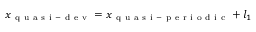<formula> <loc_0><loc_0><loc_500><loc_500>x _ { q u a s i - d e v } = x _ { q u a s i - p e r i o d i c } + l _ { 1 }</formula> 